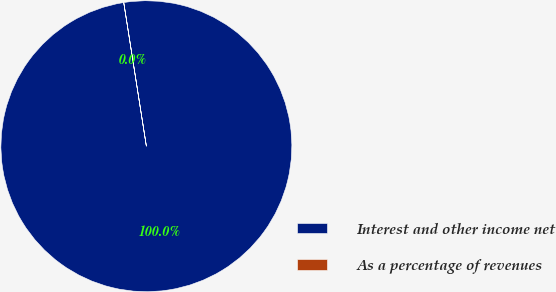<chart> <loc_0><loc_0><loc_500><loc_500><pie_chart><fcel>Interest and other income net<fcel>As a percentage of revenues<nl><fcel>99.99%<fcel>0.01%<nl></chart> 